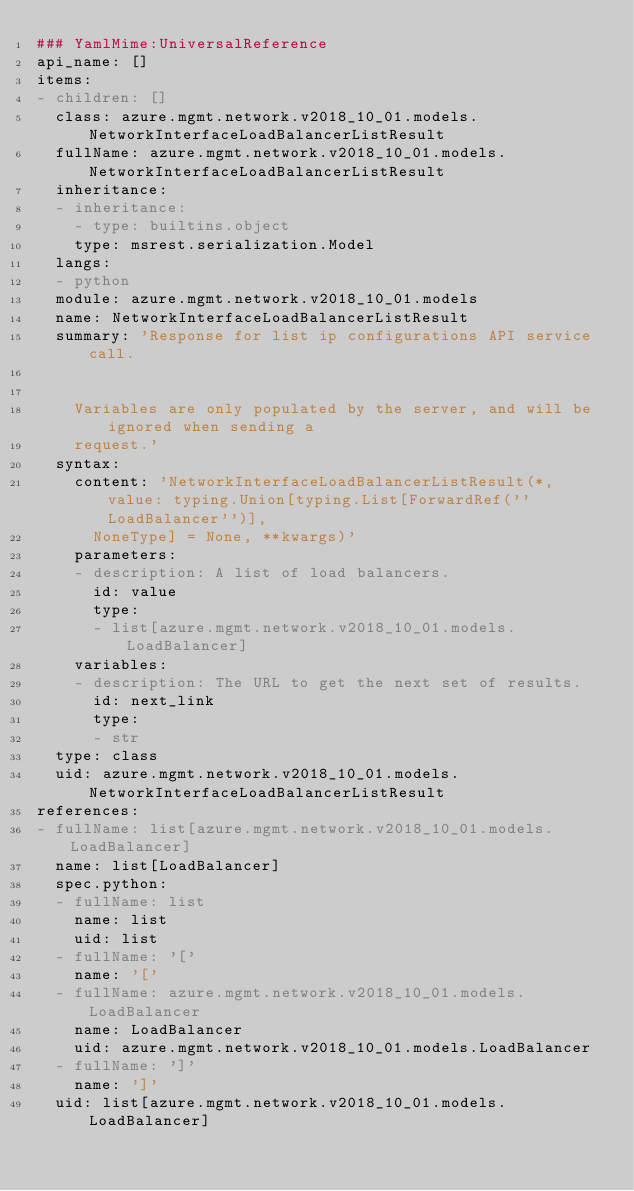<code> <loc_0><loc_0><loc_500><loc_500><_YAML_>### YamlMime:UniversalReference
api_name: []
items:
- children: []
  class: azure.mgmt.network.v2018_10_01.models.NetworkInterfaceLoadBalancerListResult
  fullName: azure.mgmt.network.v2018_10_01.models.NetworkInterfaceLoadBalancerListResult
  inheritance:
  - inheritance:
    - type: builtins.object
    type: msrest.serialization.Model
  langs:
  - python
  module: azure.mgmt.network.v2018_10_01.models
  name: NetworkInterfaceLoadBalancerListResult
  summary: 'Response for list ip configurations API service call.


    Variables are only populated by the server, and will be ignored when sending a
    request.'
  syntax:
    content: 'NetworkInterfaceLoadBalancerListResult(*, value: typing.Union[typing.List[ForwardRef(''LoadBalancer'')],
      NoneType] = None, **kwargs)'
    parameters:
    - description: A list of load balancers.
      id: value
      type:
      - list[azure.mgmt.network.v2018_10_01.models.LoadBalancer]
    variables:
    - description: The URL to get the next set of results.
      id: next_link
      type:
      - str
  type: class
  uid: azure.mgmt.network.v2018_10_01.models.NetworkInterfaceLoadBalancerListResult
references:
- fullName: list[azure.mgmt.network.v2018_10_01.models.LoadBalancer]
  name: list[LoadBalancer]
  spec.python:
  - fullName: list
    name: list
    uid: list
  - fullName: '['
    name: '['
  - fullName: azure.mgmt.network.v2018_10_01.models.LoadBalancer
    name: LoadBalancer
    uid: azure.mgmt.network.v2018_10_01.models.LoadBalancer
  - fullName: ']'
    name: ']'
  uid: list[azure.mgmt.network.v2018_10_01.models.LoadBalancer]
</code> 